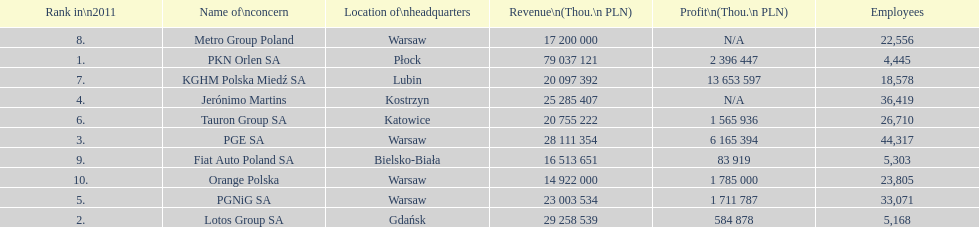What company is the only one with a revenue greater than 75,000,000 thou. pln? PKN Orlen SA. 